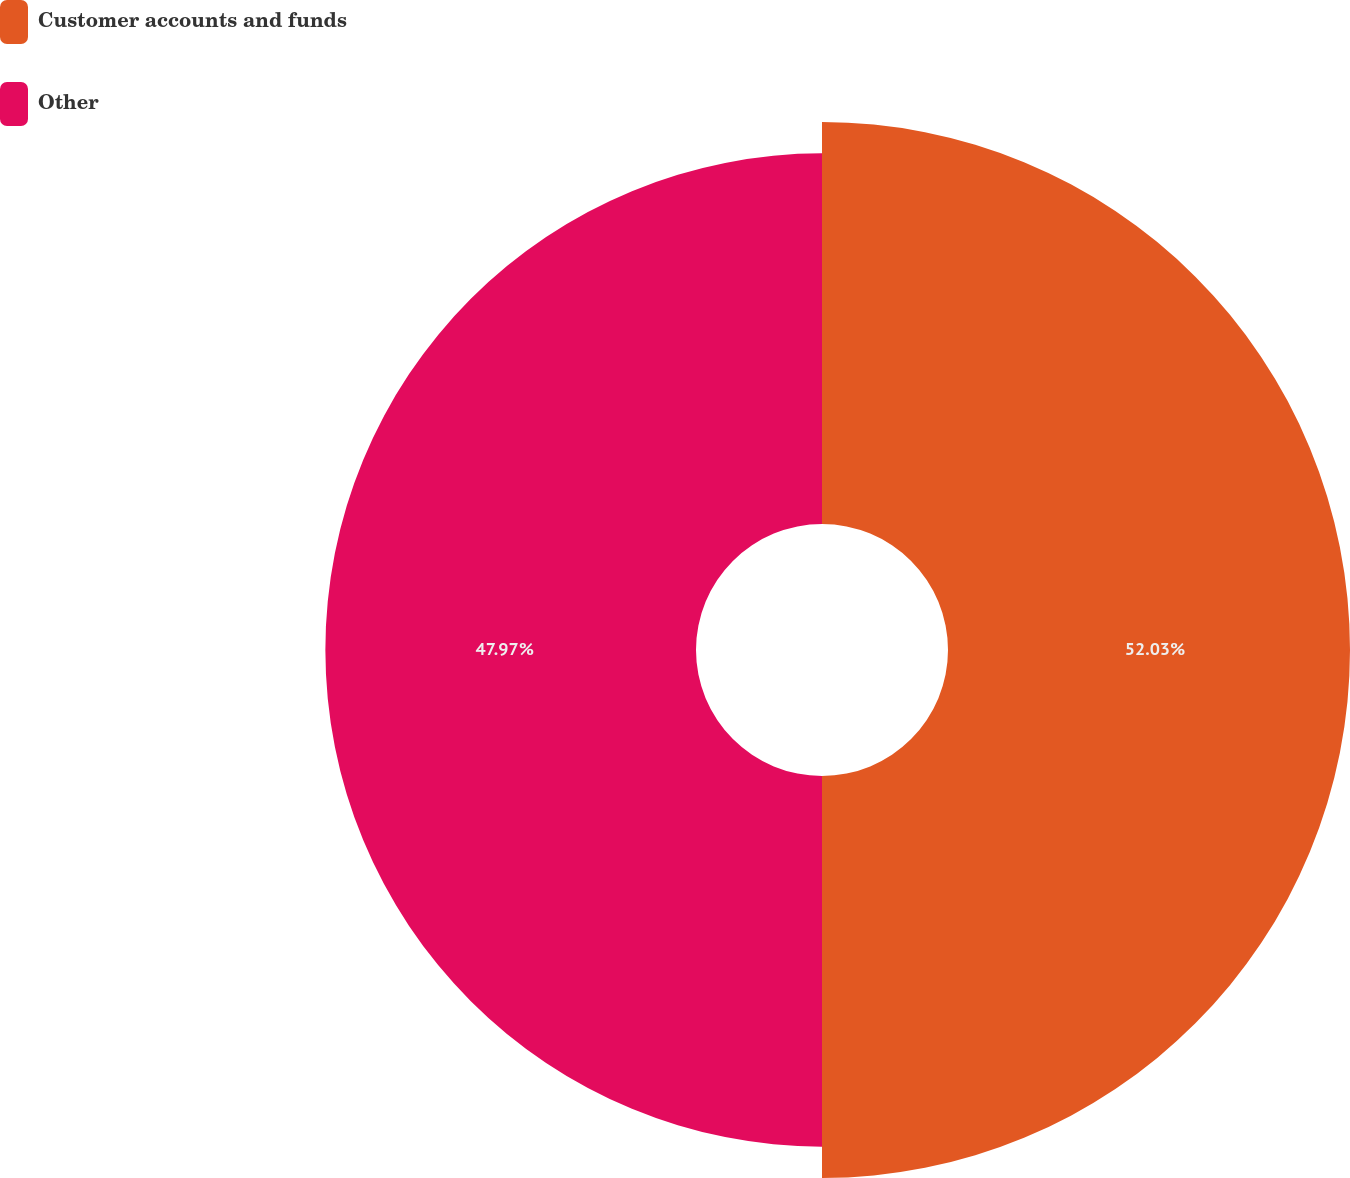<chart> <loc_0><loc_0><loc_500><loc_500><pie_chart><fcel>Customer accounts and funds<fcel>Other<nl><fcel>52.03%<fcel>47.97%<nl></chart> 